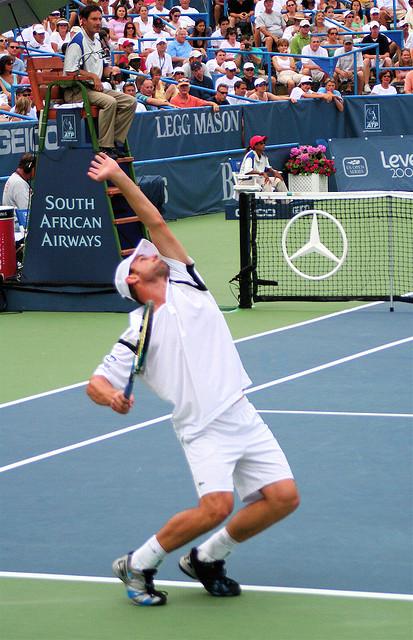What car brand is advertised?
Write a very short answer. Mercedes. What is in the guys left hand?
Keep it brief. Nothing. What airline is advertised?
Write a very short answer. South african airways. 